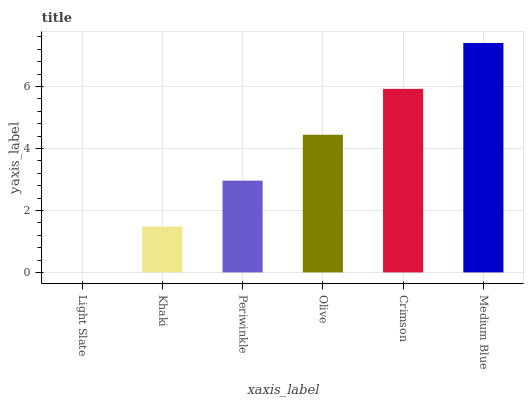Is Light Slate the minimum?
Answer yes or no. Yes. Is Medium Blue the maximum?
Answer yes or no. Yes. Is Khaki the minimum?
Answer yes or no. No. Is Khaki the maximum?
Answer yes or no. No. Is Khaki greater than Light Slate?
Answer yes or no. Yes. Is Light Slate less than Khaki?
Answer yes or no. Yes. Is Light Slate greater than Khaki?
Answer yes or no. No. Is Khaki less than Light Slate?
Answer yes or no. No. Is Olive the high median?
Answer yes or no. Yes. Is Periwinkle the low median?
Answer yes or no. Yes. Is Crimson the high median?
Answer yes or no. No. Is Crimson the low median?
Answer yes or no. No. 